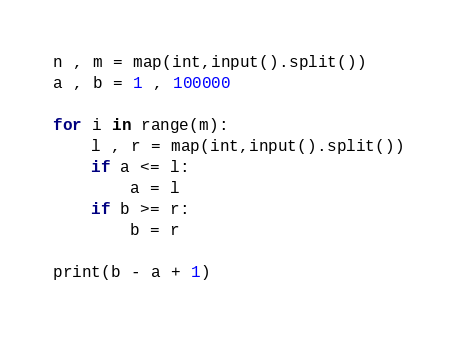Convert code to text. <code><loc_0><loc_0><loc_500><loc_500><_Python_>n , m = map(int,input().split())
a , b = 1 , 100000

for i in range(m):
    l , r = map(int,input().split())
    if a <= l:
        a = l
    if b >= r:
        b = r
        
print(b - a + 1)</code> 